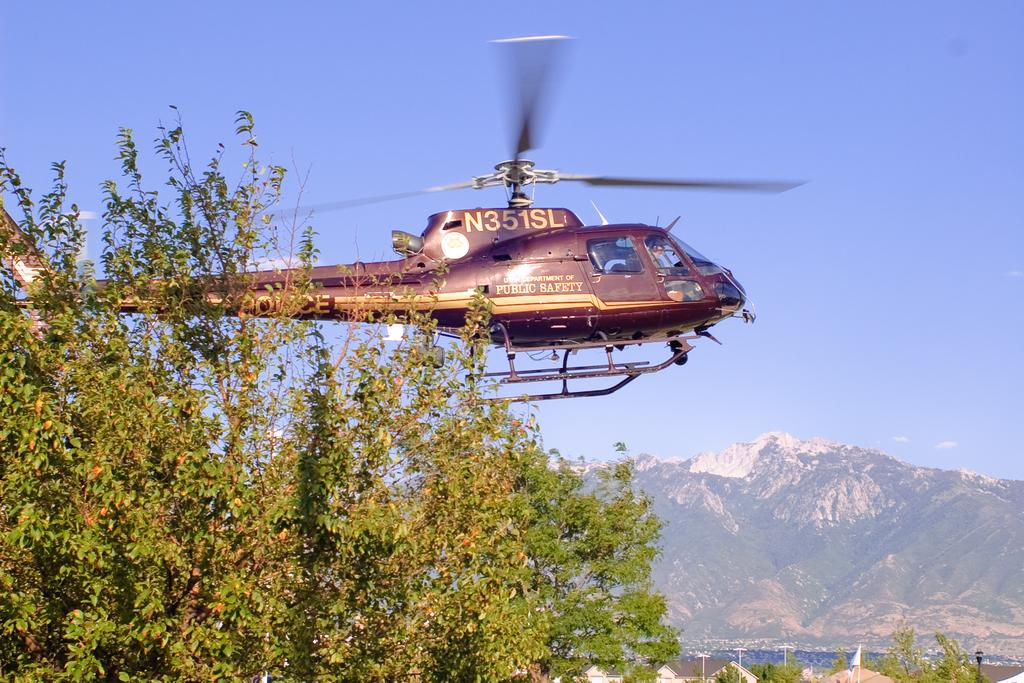<image>
Write a terse but informative summary of the picture. Utah Department of Public Safety brown helicopter with N351SL wrote on the side. 